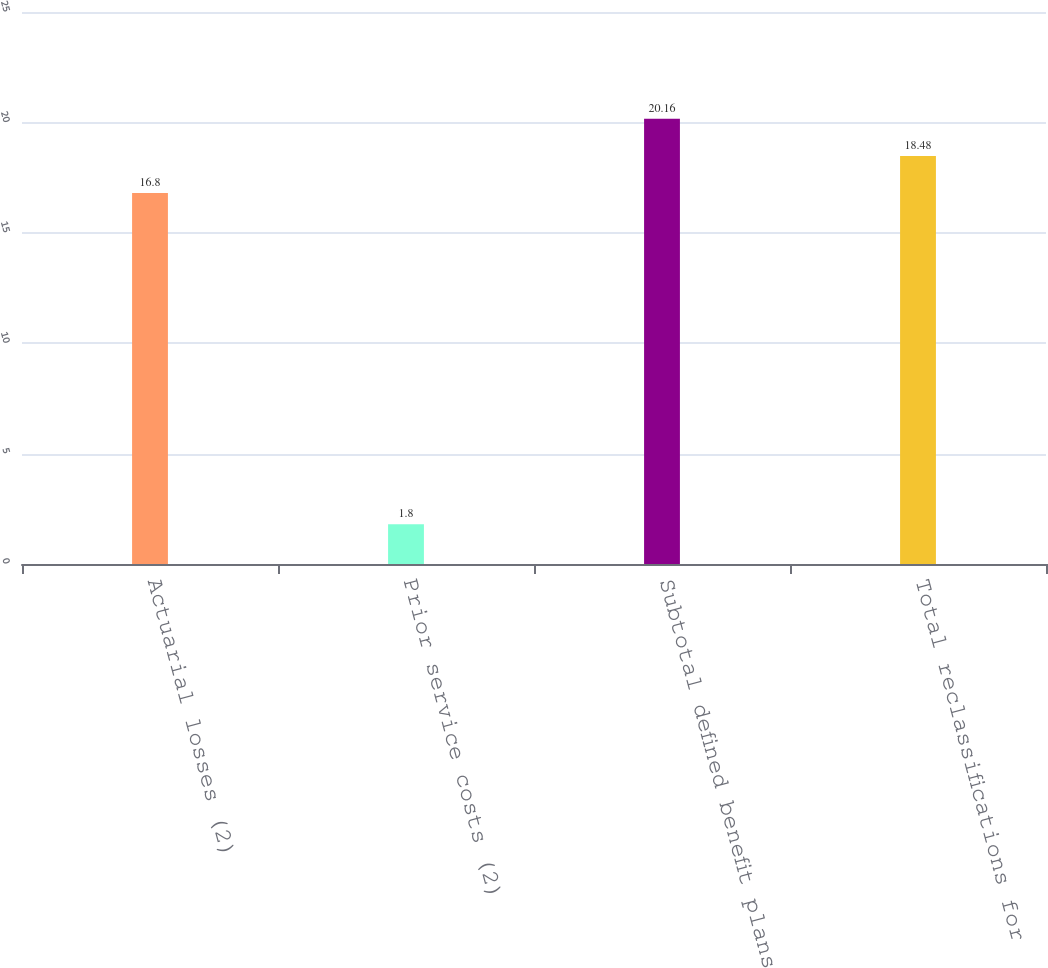<chart> <loc_0><loc_0><loc_500><loc_500><bar_chart><fcel>Actuarial losses (2)<fcel>Prior service costs (2)<fcel>Subtotal defined benefit plans<fcel>Total reclassifications for<nl><fcel>16.8<fcel>1.8<fcel>20.16<fcel>18.48<nl></chart> 